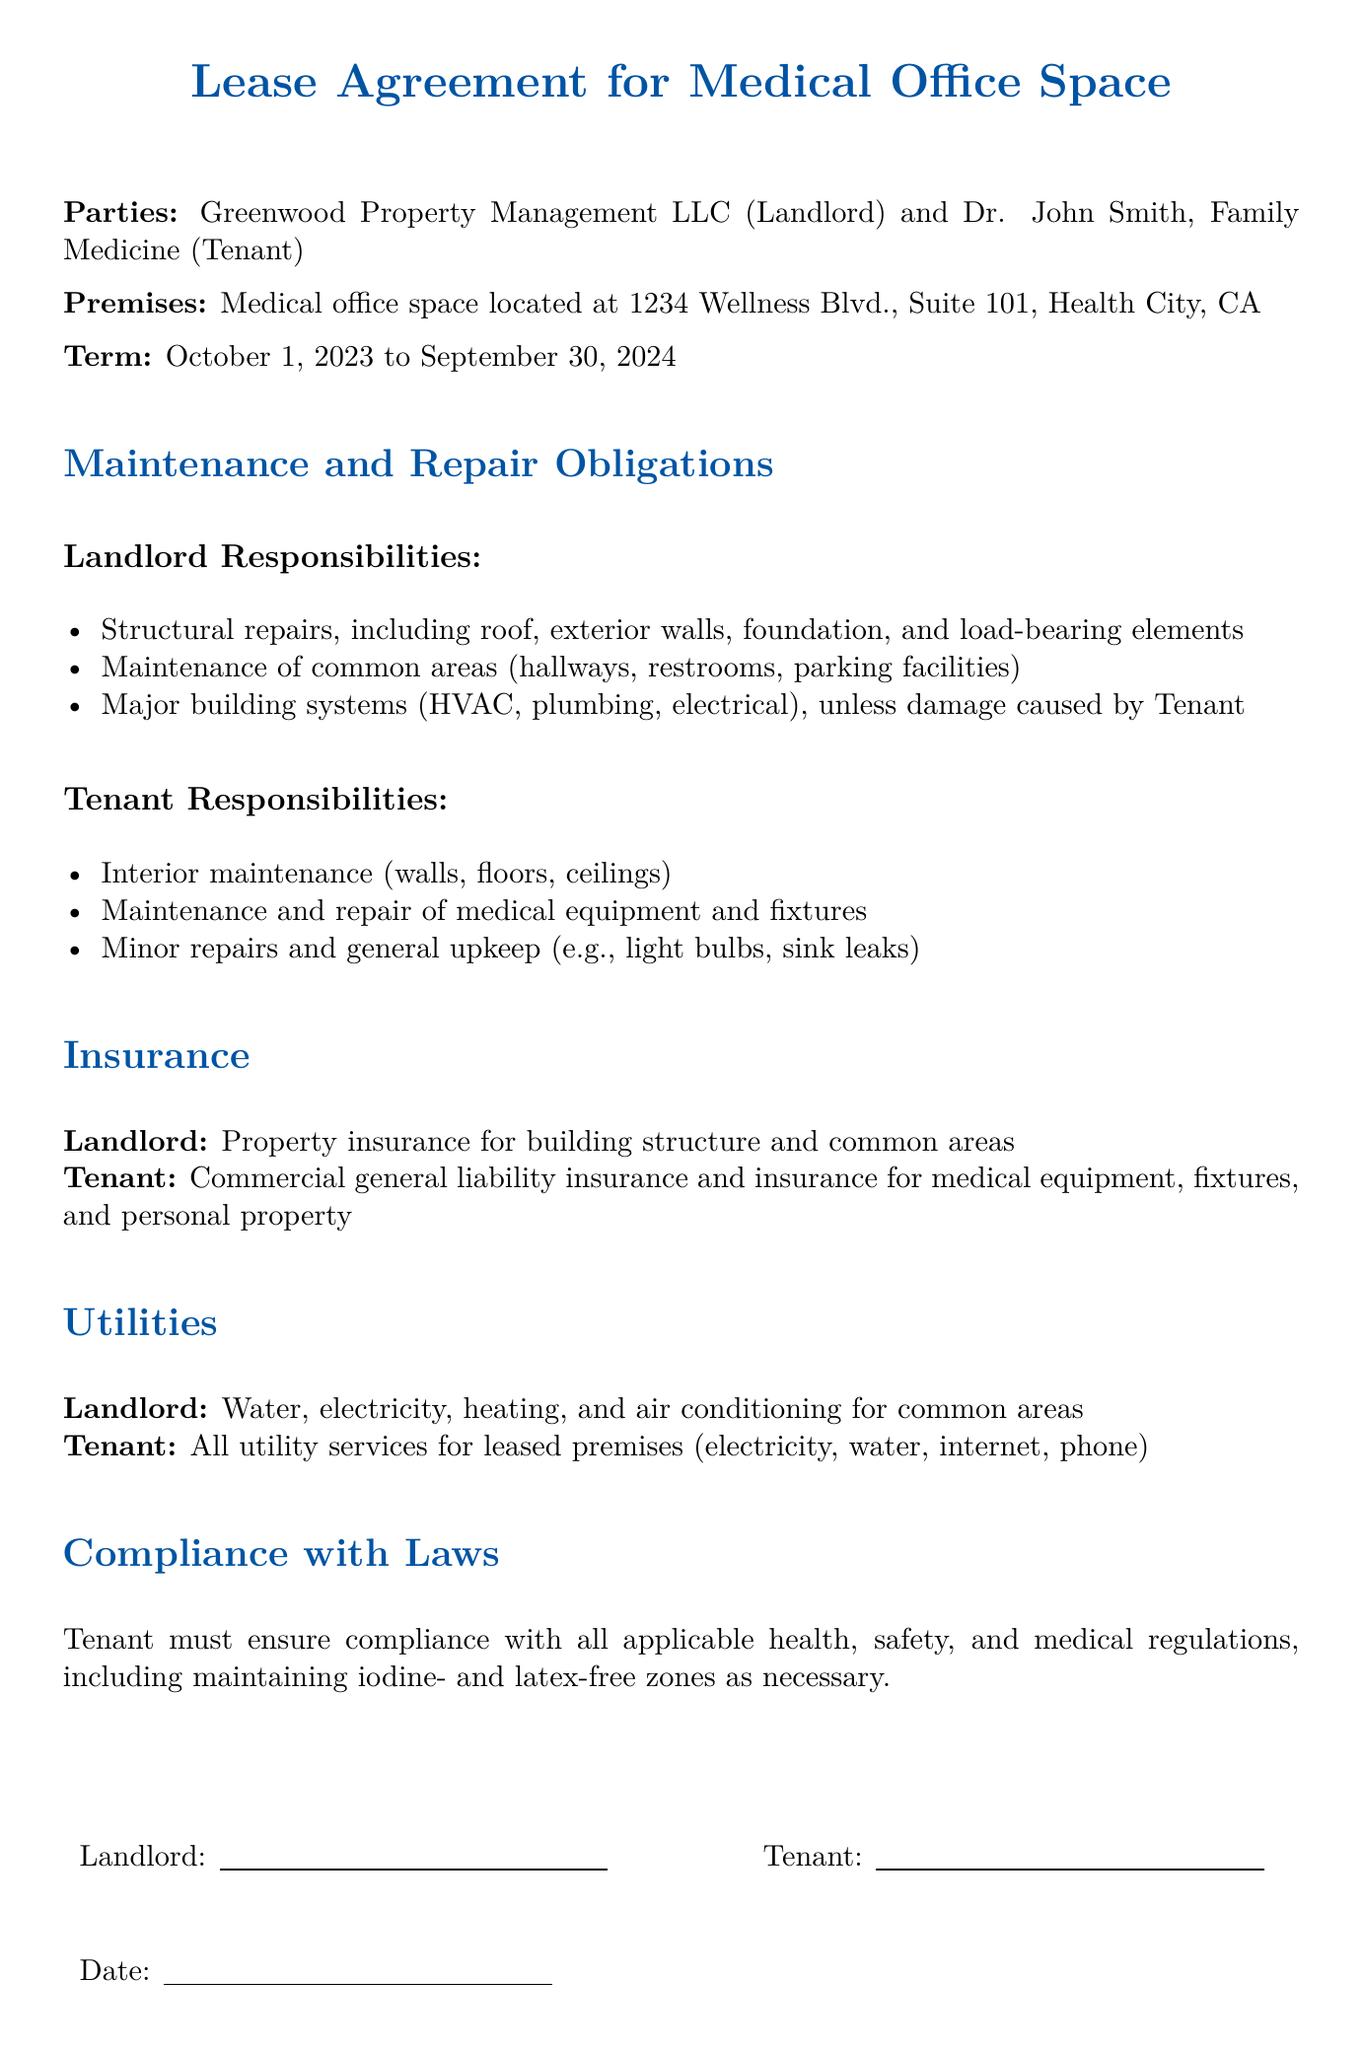what is the landlord's name? The landlord's name is stated at the beginning of the document as Greenwood Property Management LLC.
Answer: Greenwood Property Management LLC what date does the lease term start? The lease begins on October 1, 2023, as mentioned in the term section.
Answer: October 1, 2023 which responsibilities include maintenance of common areas? The landlord is responsible for maintaining common areas like hallways, restrooms, and parking facilities.
Answer: Landlord who is responsible for minor repairs? The tenant is responsible for minor repairs and general upkeep, as listed under tenant responsibilities.
Answer: Tenant what type of insurance must the tenant carry? The tenant is required to have commercial general liability insurance and insurance for medical equipment.
Answer: Commercial general liability insurance what is covered by the landlord's insurance? The landlord's insurance covers the building structure and common areas.
Answer: Building structure and common areas which part of the property is the tenant responsible for maintaining? The tenant is responsible for maintaining the interior, including walls, floors, and ceilings.
Answer: Interior how long is the lease term? The lease term lasts for one year, from October 1, 2023, to September 30, 2024.
Answer: One year what must the tenant ensure compliance with? The tenant must ensure compliance with all applicable health, safety, and medical regulations.
Answer: Health, safety, and medical regulations 